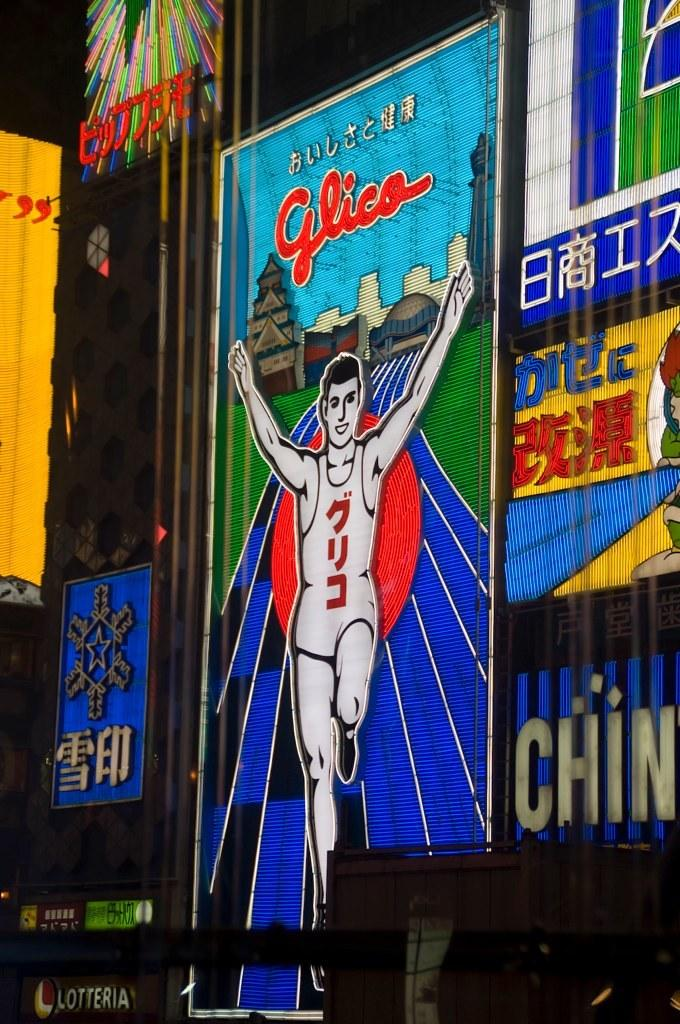<image>
Relay a brief, clear account of the picture shown. An advertisement depicts a runner under the word GLICO. 